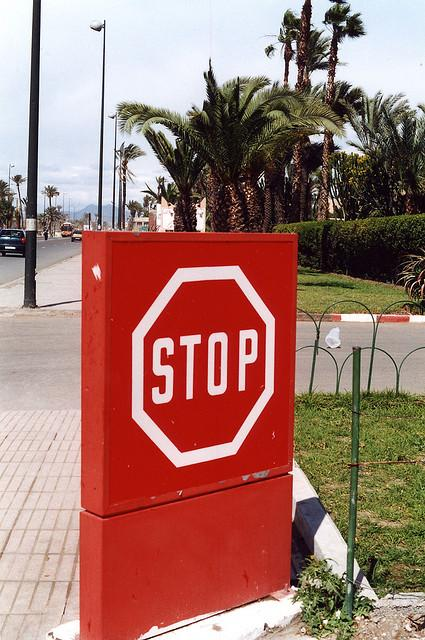Where can we find the sign above? Please explain your reasoning. road. This is a traffic sign used to let drivers know what they can or should do 